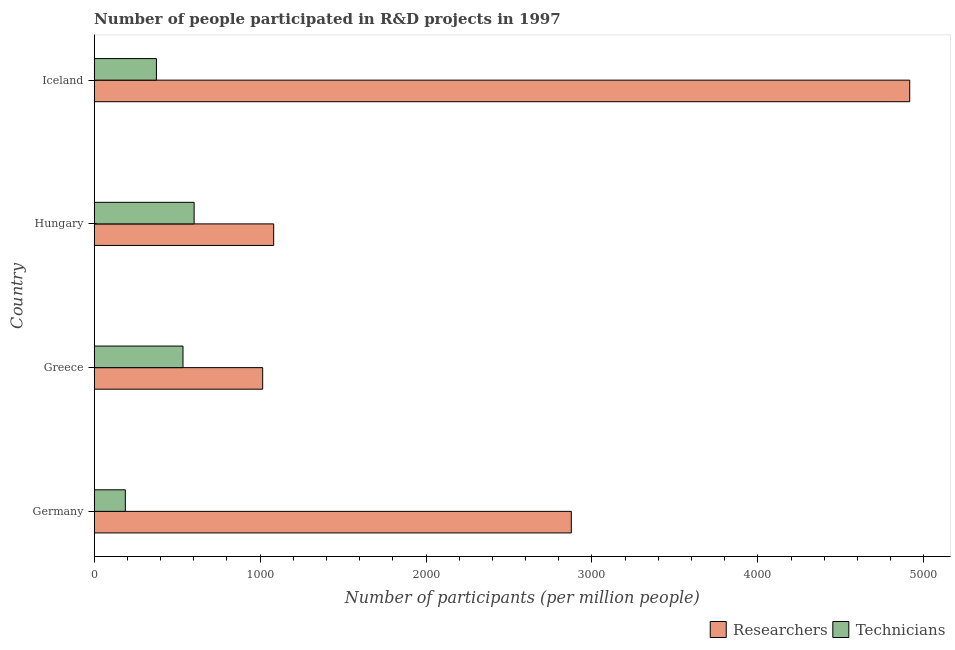How many different coloured bars are there?
Offer a very short reply. 2. Are the number of bars per tick equal to the number of legend labels?
Offer a very short reply. Yes. How many bars are there on the 3rd tick from the top?
Ensure brevity in your answer.  2. What is the label of the 2nd group of bars from the top?
Offer a very short reply. Hungary. In how many cases, is the number of bars for a given country not equal to the number of legend labels?
Your answer should be very brief. 0. What is the number of researchers in Germany?
Your response must be concise. 2875.74. Across all countries, what is the maximum number of technicians?
Provide a succinct answer. 602.3. Across all countries, what is the minimum number of technicians?
Provide a succinct answer. 187.58. What is the total number of technicians in the graph?
Your response must be concise. 1700.09. What is the difference between the number of technicians in Greece and that in Iceland?
Your answer should be compact. 160.24. What is the difference between the number of technicians in Hungary and the number of researchers in Greece?
Your answer should be compact. -413.1. What is the average number of technicians per country?
Your response must be concise. 425.02. What is the difference between the number of technicians and number of researchers in Hungary?
Offer a terse response. -479.44. In how many countries, is the number of technicians greater than 4400 ?
Give a very brief answer. 0. What is the ratio of the number of researchers in Greece to that in Iceland?
Offer a very short reply. 0.21. Is the difference between the number of researchers in Germany and Greece greater than the difference between the number of technicians in Germany and Greece?
Offer a terse response. Yes. What is the difference between the highest and the second highest number of technicians?
Provide a succinct answer. 67.07. What is the difference between the highest and the lowest number of researchers?
Make the answer very short. 3899.97. In how many countries, is the number of researchers greater than the average number of researchers taken over all countries?
Your answer should be very brief. 2. What does the 1st bar from the top in Greece represents?
Provide a succinct answer. Technicians. What does the 2nd bar from the bottom in Hungary represents?
Offer a very short reply. Technicians. Are all the bars in the graph horizontal?
Your answer should be very brief. Yes. How many countries are there in the graph?
Provide a short and direct response. 4. Does the graph contain grids?
Your response must be concise. No. Where does the legend appear in the graph?
Your response must be concise. Bottom right. How many legend labels are there?
Your answer should be very brief. 2. How are the legend labels stacked?
Offer a very short reply. Horizontal. What is the title of the graph?
Keep it short and to the point. Number of people participated in R&D projects in 1997. Does "Private consumption" appear as one of the legend labels in the graph?
Keep it short and to the point. No. What is the label or title of the X-axis?
Provide a succinct answer. Number of participants (per million people). What is the Number of participants (per million people) of Researchers in Germany?
Provide a short and direct response. 2875.74. What is the Number of participants (per million people) of Technicians in Germany?
Offer a terse response. 187.58. What is the Number of participants (per million people) of Researchers in Greece?
Ensure brevity in your answer.  1015.39. What is the Number of participants (per million people) of Technicians in Greece?
Provide a short and direct response. 535.23. What is the Number of participants (per million people) in Researchers in Hungary?
Keep it short and to the point. 1081.73. What is the Number of participants (per million people) of Technicians in Hungary?
Keep it short and to the point. 602.3. What is the Number of participants (per million people) of Researchers in Iceland?
Provide a succinct answer. 4915.36. What is the Number of participants (per million people) of Technicians in Iceland?
Ensure brevity in your answer.  374.99. Across all countries, what is the maximum Number of participants (per million people) of Researchers?
Your response must be concise. 4915.36. Across all countries, what is the maximum Number of participants (per million people) in Technicians?
Offer a terse response. 602.3. Across all countries, what is the minimum Number of participants (per million people) in Researchers?
Offer a terse response. 1015.39. Across all countries, what is the minimum Number of participants (per million people) of Technicians?
Ensure brevity in your answer.  187.58. What is the total Number of participants (per million people) of Researchers in the graph?
Ensure brevity in your answer.  9888.23. What is the total Number of participants (per million people) in Technicians in the graph?
Provide a short and direct response. 1700.09. What is the difference between the Number of participants (per million people) in Researchers in Germany and that in Greece?
Ensure brevity in your answer.  1860.35. What is the difference between the Number of participants (per million people) of Technicians in Germany and that in Greece?
Provide a succinct answer. -347.65. What is the difference between the Number of participants (per million people) of Researchers in Germany and that in Hungary?
Ensure brevity in your answer.  1794.01. What is the difference between the Number of participants (per million people) of Technicians in Germany and that in Hungary?
Keep it short and to the point. -414.72. What is the difference between the Number of participants (per million people) of Researchers in Germany and that in Iceland?
Provide a short and direct response. -2039.62. What is the difference between the Number of participants (per million people) in Technicians in Germany and that in Iceland?
Your answer should be compact. -187.41. What is the difference between the Number of participants (per million people) in Researchers in Greece and that in Hungary?
Offer a terse response. -66.34. What is the difference between the Number of participants (per million people) of Technicians in Greece and that in Hungary?
Provide a succinct answer. -67.07. What is the difference between the Number of participants (per million people) of Researchers in Greece and that in Iceland?
Provide a short and direct response. -3899.97. What is the difference between the Number of participants (per million people) in Technicians in Greece and that in Iceland?
Give a very brief answer. 160.24. What is the difference between the Number of participants (per million people) in Researchers in Hungary and that in Iceland?
Your answer should be very brief. -3833.63. What is the difference between the Number of participants (per million people) of Technicians in Hungary and that in Iceland?
Keep it short and to the point. 227.3. What is the difference between the Number of participants (per million people) of Researchers in Germany and the Number of participants (per million people) of Technicians in Greece?
Offer a terse response. 2340.51. What is the difference between the Number of participants (per million people) in Researchers in Germany and the Number of participants (per million people) in Technicians in Hungary?
Provide a short and direct response. 2273.44. What is the difference between the Number of participants (per million people) in Researchers in Germany and the Number of participants (per million people) in Technicians in Iceland?
Ensure brevity in your answer.  2500.75. What is the difference between the Number of participants (per million people) in Researchers in Greece and the Number of participants (per million people) in Technicians in Hungary?
Provide a succinct answer. 413.1. What is the difference between the Number of participants (per million people) of Researchers in Greece and the Number of participants (per million people) of Technicians in Iceland?
Your answer should be very brief. 640.4. What is the difference between the Number of participants (per million people) in Researchers in Hungary and the Number of participants (per million people) in Technicians in Iceland?
Make the answer very short. 706.74. What is the average Number of participants (per million people) in Researchers per country?
Keep it short and to the point. 2472.06. What is the average Number of participants (per million people) in Technicians per country?
Offer a very short reply. 425.02. What is the difference between the Number of participants (per million people) in Researchers and Number of participants (per million people) in Technicians in Germany?
Offer a terse response. 2688.16. What is the difference between the Number of participants (per million people) of Researchers and Number of participants (per million people) of Technicians in Greece?
Provide a succinct answer. 480.17. What is the difference between the Number of participants (per million people) in Researchers and Number of participants (per million people) in Technicians in Hungary?
Offer a very short reply. 479.44. What is the difference between the Number of participants (per million people) of Researchers and Number of participants (per million people) of Technicians in Iceland?
Your answer should be very brief. 4540.37. What is the ratio of the Number of participants (per million people) of Researchers in Germany to that in Greece?
Give a very brief answer. 2.83. What is the ratio of the Number of participants (per million people) of Technicians in Germany to that in Greece?
Make the answer very short. 0.35. What is the ratio of the Number of participants (per million people) in Researchers in Germany to that in Hungary?
Offer a very short reply. 2.66. What is the ratio of the Number of participants (per million people) of Technicians in Germany to that in Hungary?
Give a very brief answer. 0.31. What is the ratio of the Number of participants (per million people) of Researchers in Germany to that in Iceland?
Offer a very short reply. 0.59. What is the ratio of the Number of participants (per million people) of Technicians in Germany to that in Iceland?
Your response must be concise. 0.5. What is the ratio of the Number of participants (per million people) of Researchers in Greece to that in Hungary?
Ensure brevity in your answer.  0.94. What is the ratio of the Number of participants (per million people) of Technicians in Greece to that in Hungary?
Provide a short and direct response. 0.89. What is the ratio of the Number of participants (per million people) in Researchers in Greece to that in Iceland?
Make the answer very short. 0.21. What is the ratio of the Number of participants (per million people) of Technicians in Greece to that in Iceland?
Give a very brief answer. 1.43. What is the ratio of the Number of participants (per million people) of Researchers in Hungary to that in Iceland?
Your answer should be very brief. 0.22. What is the ratio of the Number of participants (per million people) in Technicians in Hungary to that in Iceland?
Offer a terse response. 1.61. What is the difference between the highest and the second highest Number of participants (per million people) in Researchers?
Offer a terse response. 2039.62. What is the difference between the highest and the second highest Number of participants (per million people) of Technicians?
Ensure brevity in your answer.  67.07. What is the difference between the highest and the lowest Number of participants (per million people) in Researchers?
Your answer should be compact. 3899.97. What is the difference between the highest and the lowest Number of participants (per million people) of Technicians?
Give a very brief answer. 414.72. 